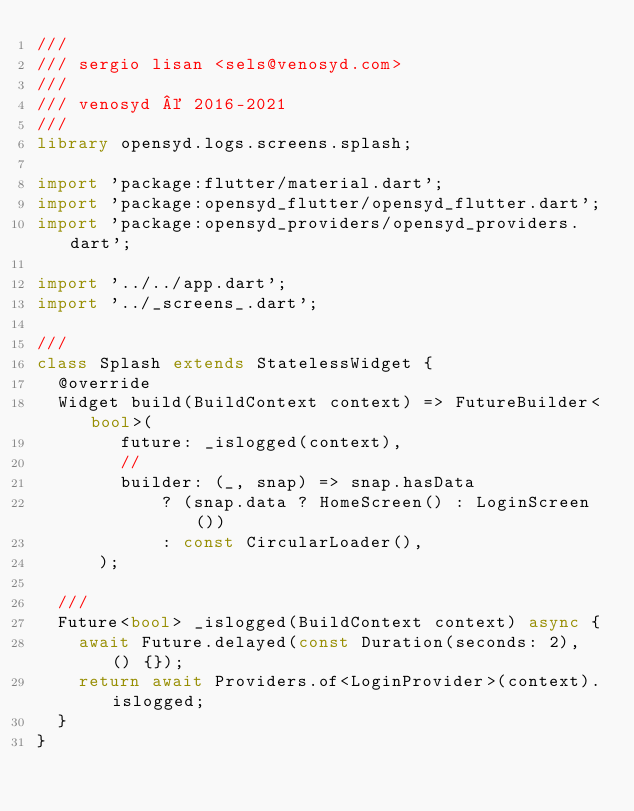Convert code to text. <code><loc_0><loc_0><loc_500><loc_500><_Dart_>///
/// sergio lisan <sels@venosyd.com>
///
/// venosyd © 2016-2021
///
library opensyd.logs.screens.splash;

import 'package:flutter/material.dart';
import 'package:opensyd_flutter/opensyd_flutter.dart';
import 'package:opensyd_providers/opensyd_providers.dart';

import '../../app.dart';
import '../_screens_.dart';

///
class Splash extends StatelessWidget {
  @override
  Widget build(BuildContext context) => FutureBuilder<bool>(
        future: _islogged(context),
        //
        builder: (_, snap) => snap.hasData
            ? (snap.data ? HomeScreen() : LoginScreen())
            : const CircularLoader(),
      );

  ///
  Future<bool> _islogged(BuildContext context) async {
    await Future.delayed(const Duration(seconds: 2), () {});
    return await Providers.of<LoginProvider>(context).islogged;
  }
}
</code> 